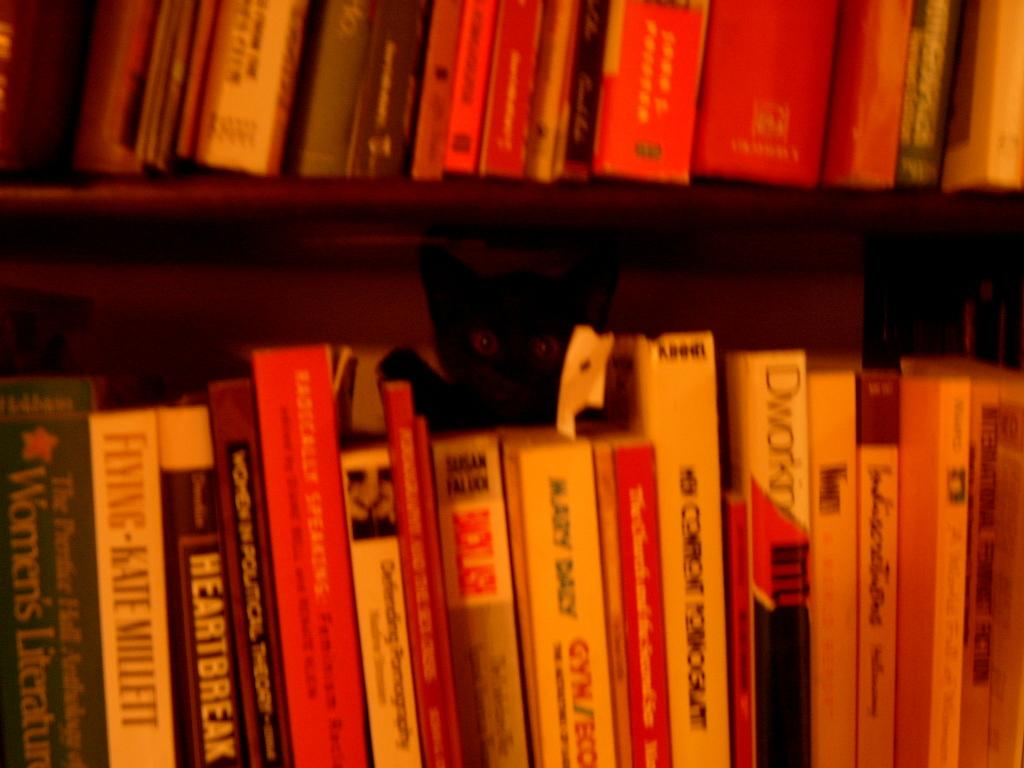What type of furniture is present in the image? There is a cupboard in the image. What items can be found inside the cupboard? The cupboard contains books. Where is the image taken? The image is taken in a room. What type of noise can be heard coming from the cupboard in the image? There is no indication of any noise coming from the cupboard in the image. What type of trousers is the cupboard wearing in the image? The cupboard is an inanimate object and does not wear trousers. 